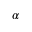<formula> <loc_0><loc_0><loc_500><loc_500>\alpha</formula> 